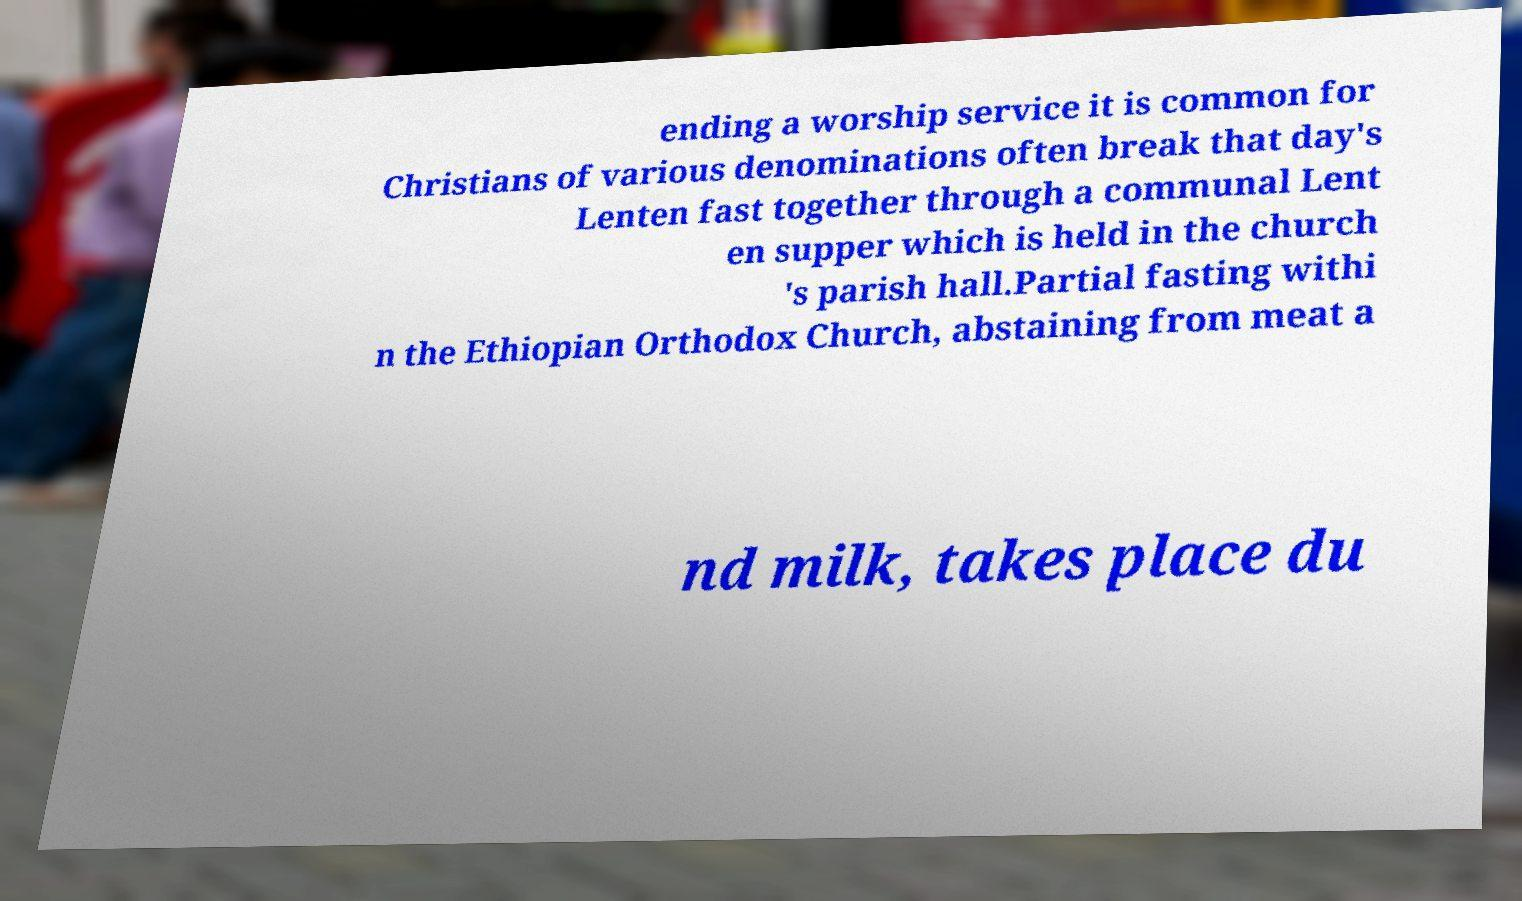Could you assist in decoding the text presented in this image and type it out clearly? ending a worship service it is common for Christians of various denominations often break that day's Lenten fast together through a communal Lent en supper which is held in the church 's parish hall.Partial fasting withi n the Ethiopian Orthodox Church, abstaining from meat a nd milk, takes place du 